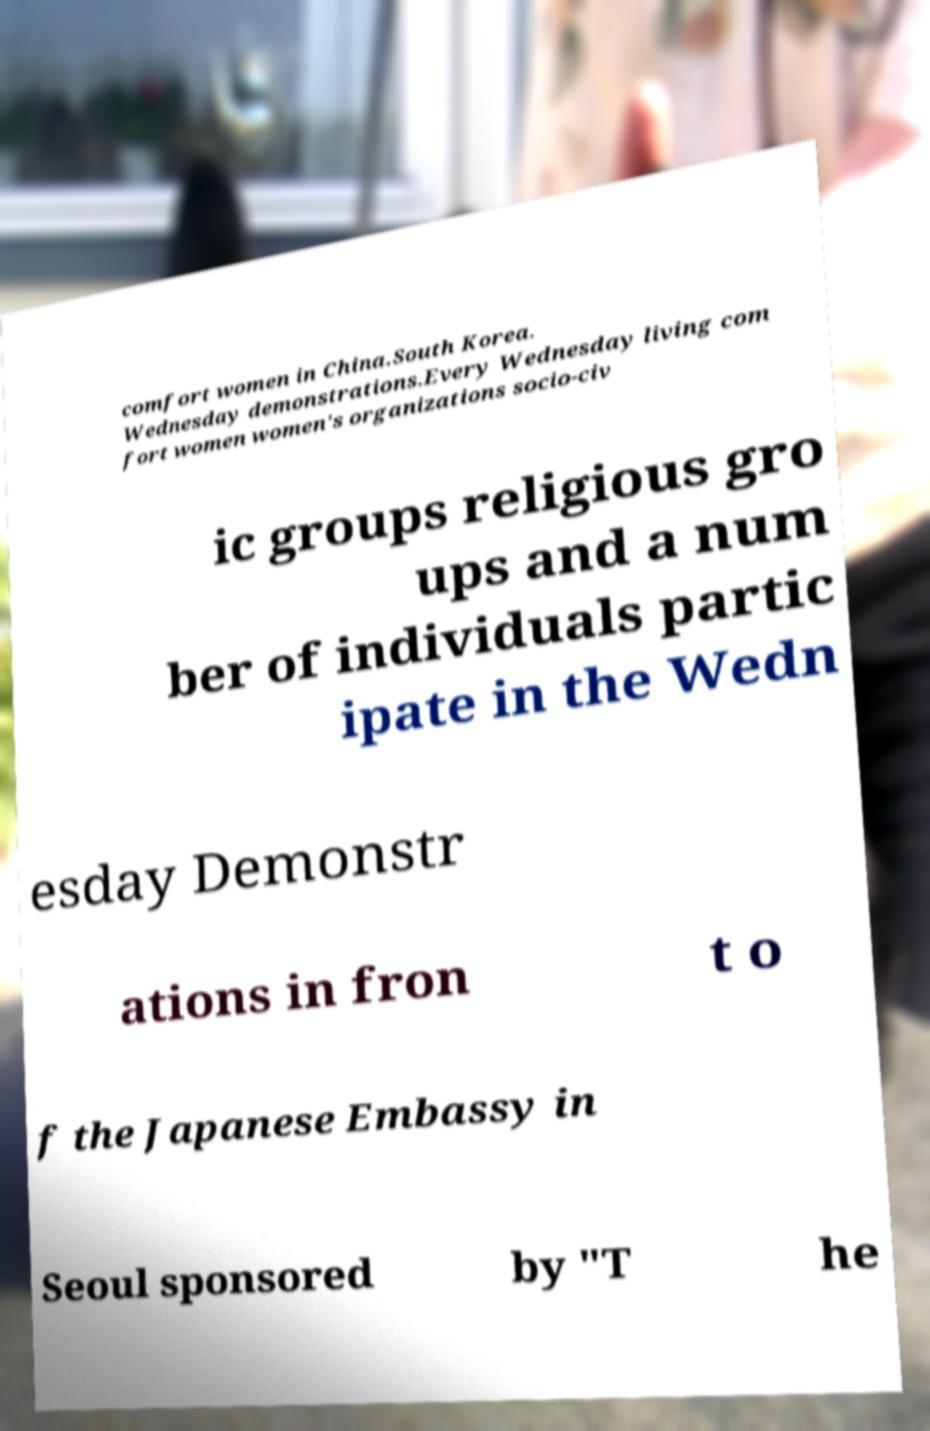Please identify and transcribe the text found in this image. comfort women in China.South Korea. Wednesday demonstrations.Every Wednesday living com fort women women's organizations socio-civ ic groups religious gro ups and a num ber of individuals partic ipate in the Wedn esday Demonstr ations in fron t o f the Japanese Embassy in Seoul sponsored by "T he 